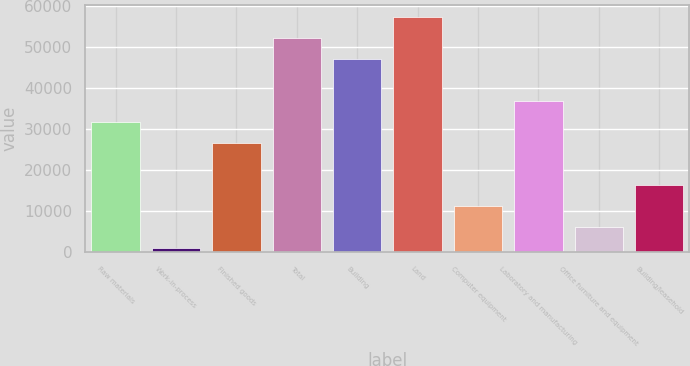<chart> <loc_0><loc_0><loc_500><loc_500><bar_chart><fcel>Raw materials<fcel>Work-in-process<fcel>Finished goods<fcel>Total<fcel>Building<fcel>Land<fcel>Computer equipment<fcel>Laboratory and manufacturing<fcel>Office furniture and equipment<fcel>Building/leasehold<nl><fcel>31697.8<fcel>907<fcel>26566<fcel>52225<fcel>47093.2<fcel>57356.8<fcel>11170.6<fcel>36829.6<fcel>6038.8<fcel>16302.4<nl></chart> 